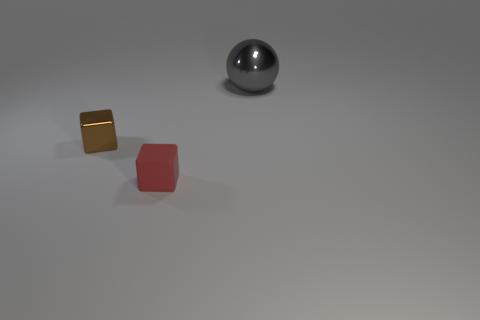Is there any other thing that has the same size as the gray metallic ball?
Give a very brief answer. No. What number of other things are there of the same material as the tiny brown object
Keep it short and to the point. 1. How many brown objects are big shiny balls or shiny objects?
Make the answer very short. 1. How many balls have the same size as the brown object?
Your response must be concise. 0. How many objects are large brown balls or shiny things that are to the left of the sphere?
Ensure brevity in your answer.  1. Does the block that is in front of the metal block have the same size as the object that is behind the brown object?
Ensure brevity in your answer.  No. How many other small shiny objects have the same shape as the gray metal thing?
Provide a short and direct response. 0. What is the shape of the small brown thing that is made of the same material as the big thing?
Your answer should be very brief. Cube. The tiny cube that is behind the cube to the right of the shiny object that is to the left of the large gray metal ball is made of what material?
Your answer should be compact. Metal. There is a red thing; does it have the same size as the block that is to the left of the red rubber thing?
Your answer should be very brief. Yes. 